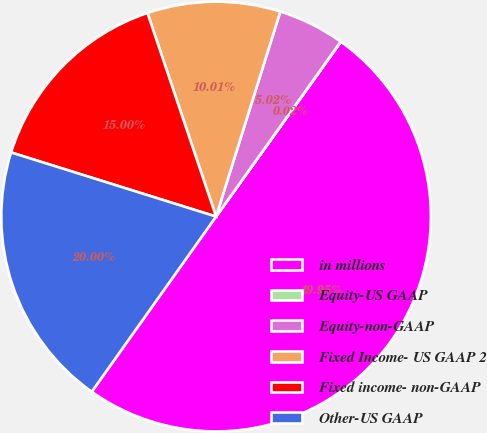Convert chart. <chart><loc_0><loc_0><loc_500><loc_500><pie_chart><fcel>in millions<fcel>Equity-US GAAP<fcel>Equity-non-GAAP<fcel>Fixed Income- US GAAP 2<fcel>Fixed income- non-GAAP<fcel>Other-US GAAP<nl><fcel>49.95%<fcel>0.02%<fcel>5.02%<fcel>10.01%<fcel>15.0%<fcel>20.0%<nl></chart> 